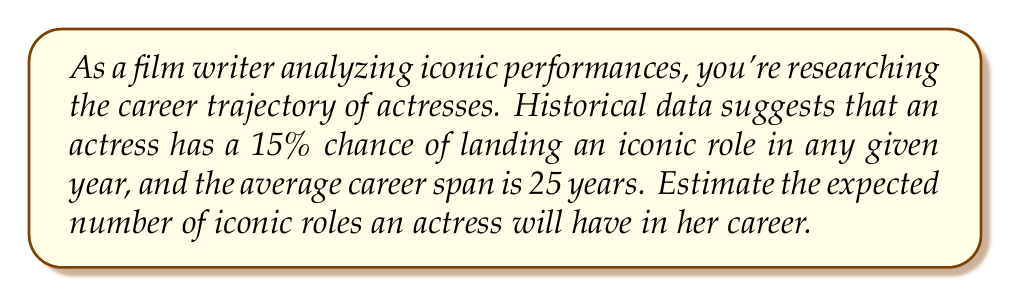What is the answer to this math problem? To solve this problem, we'll use the concept of expected value. Let's break it down step-by-step:

1) First, we need to identify the probability of success (p) and the number of trials (n):
   p = 15% = 0.15 (probability of landing an iconic role in a year)
   n = 25 (average career span in years)

2) In this scenario, we're dealing with a binomial distribution. The expected value of a binomial distribution is given by the formula:

   $$ E(X) = np $$

   Where:
   E(X) is the expected value
   n is the number of trials
   p is the probability of success on each trial

3) Let's substitute our values into the formula:

   $$ E(X) = 25 * 0.15 $$

4) Now we can calculate:

   $$ E(X) = 3.75 $$

This means that, on average, an actress can expect to have 3.75 iconic roles in her 25-year career.
Answer: 3.75 iconic roles 